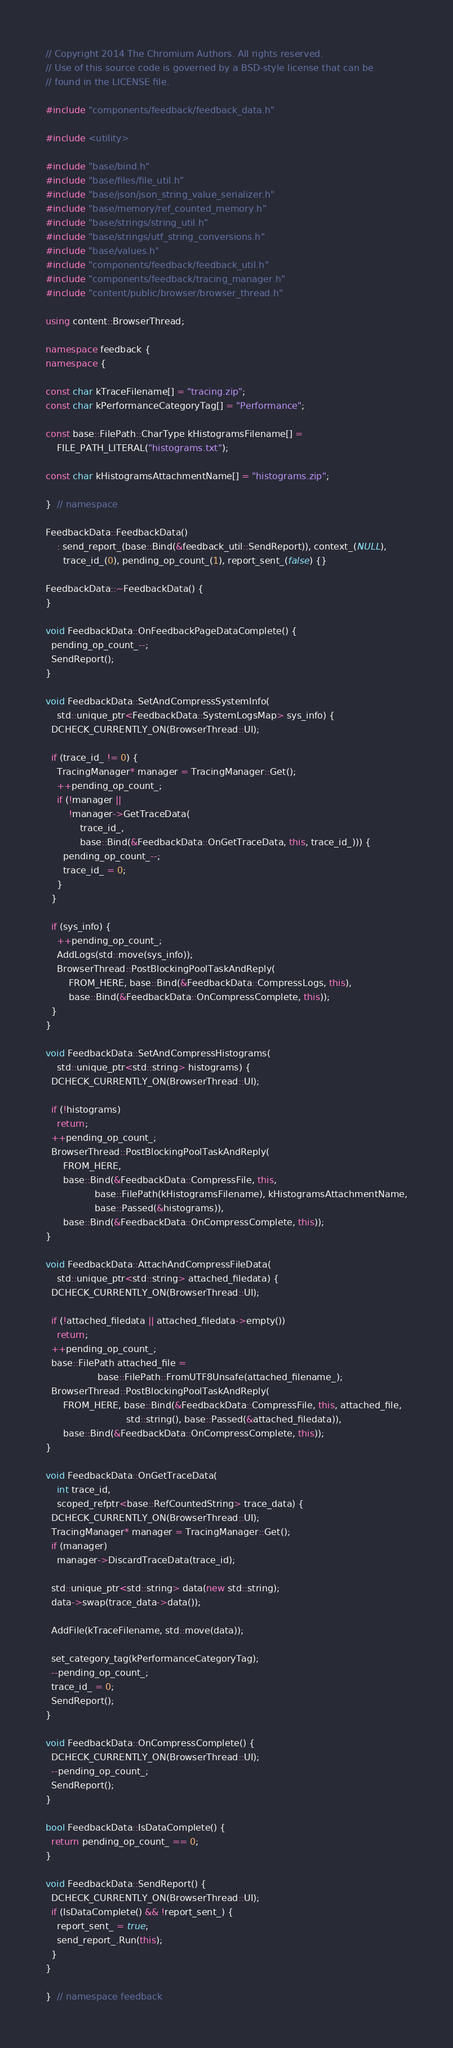<code> <loc_0><loc_0><loc_500><loc_500><_C++_>// Copyright 2014 The Chromium Authors. All rights reserved.
// Use of this source code is governed by a BSD-style license that can be
// found in the LICENSE file.

#include "components/feedback/feedback_data.h"

#include <utility>

#include "base/bind.h"
#include "base/files/file_util.h"
#include "base/json/json_string_value_serializer.h"
#include "base/memory/ref_counted_memory.h"
#include "base/strings/string_util.h"
#include "base/strings/utf_string_conversions.h"
#include "base/values.h"
#include "components/feedback/feedback_util.h"
#include "components/feedback/tracing_manager.h"
#include "content/public/browser/browser_thread.h"

using content::BrowserThread;

namespace feedback {
namespace {

const char kTraceFilename[] = "tracing.zip";
const char kPerformanceCategoryTag[] = "Performance";

const base::FilePath::CharType kHistogramsFilename[] =
    FILE_PATH_LITERAL("histograms.txt");

const char kHistogramsAttachmentName[] = "histograms.zip";

}  // namespace

FeedbackData::FeedbackData()
    : send_report_(base::Bind(&feedback_util::SendReport)), context_(NULL),
      trace_id_(0), pending_op_count_(1), report_sent_(false) {}

FeedbackData::~FeedbackData() {
}

void FeedbackData::OnFeedbackPageDataComplete() {
  pending_op_count_--;
  SendReport();
}

void FeedbackData::SetAndCompressSystemInfo(
    std::unique_ptr<FeedbackData::SystemLogsMap> sys_info) {
  DCHECK_CURRENTLY_ON(BrowserThread::UI);

  if (trace_id_ != 0) {
    TracingManager* manager = TracingManager::Get();
    ++pending_op_count_;
    if (!manager ||
        !manager->GetTraceData(
            trace_id_,
            base::Bind(&FeedbackData::OnGetTraceData, this, trace_id_))) {
      pending_op_count_--;
      trace_id_ = 0;
    }
  }

  if (sys_info) {
    ++pending_op_count_;
    AddLogs(std::move(sys_info));
    BrowserThread::PostBlockingPoolTaskAndReply(
        FROM_HERE, base::Bind(&FeedbackData::CompressLogs, this),
        base::Bind(&FeedbackData::OnCompressComplete, this));
  }
}

void FeedbackData::SetAndCompressHistograms(
    std::unique_ptr<std::string> histograms) {
  DCHECK_CURRENTLY_ON(BrowserThread::UI);

  if (!histograms)
    return;
  ++pending_op_count_;
  BrowserThread::PostBlockingPoolTaskAndReply(
      FROM_HERE,
      base::Bind(&FeedbackData::CompressFile, this,
                 base::FilePath(kHistogramsFilename), kHistogramsAttachmentName,
                 base::Passed(&histograms)),
      base::Bind(&FeedbackData::OnCompressComplete, this));
}

void FeedbackData::AttachAndCompressFileData(
    std::unique_ptr<std::string> attached_filedata) {
  DCHECK_CURRENTLY_ON(BrowserThread::UI);

  if (!attached_filedata || attached_filedata->empty())
    return;
  ++pending_op_count_;
  base::FilePath attached_file =
                  base::FilePath::FromUTF8Unsafe(attached_filename_);
  BrowserThread::PostBlockingPoolTaskAndReply(
      FROM_HERE, base::Bind(&FeedbackData::CompressFile, this, attached_file,
                            std::string(), base::Passed(&attached_filedata)),
      base::Bind(&FeedbackData::OnCompressComplete, this));
}

void FeedbackData::OnGetTraceData(
    int trace_id,
    scoped_refptr<base::RefCountedString> trace_data) {
  DCHECK_CURRENTLY_ON(BrowserThread::UI);
  TracingManager* manager = TracingManager::Get();
  if (manager)
    manager->DiscardTraceData(trace_id);

  std::unique_ptr<std::string> data(new std::string);
  data->swap(trace_data->data());

  AddFile(kTraceFilename, std::move(data));

  set_category_tag(kPerformanceCategoryTag);
  --pending_op_count_;
  trace_id_ = 0;
  SendReport();
}

void FeedbackData::OnCompressComplete() {
  DCHECK_CURRENTLY_ON(BrowserThread::UI);
  --pending_op_count_;
  SendReport();
}

bool FeedbackData::IsDataComplete() {
  return pending_op_count_ == 0;
}

void FeedbackData::SendReport() {
  DCHECK_CURRENTLY_ON(BrowserThread::UI);
  if (IsDataComplete() && !report_sent_) {
    report_sent_ = true;
    send_report_.Run(this);
  }
}

}  // namespace feedback
</code> 